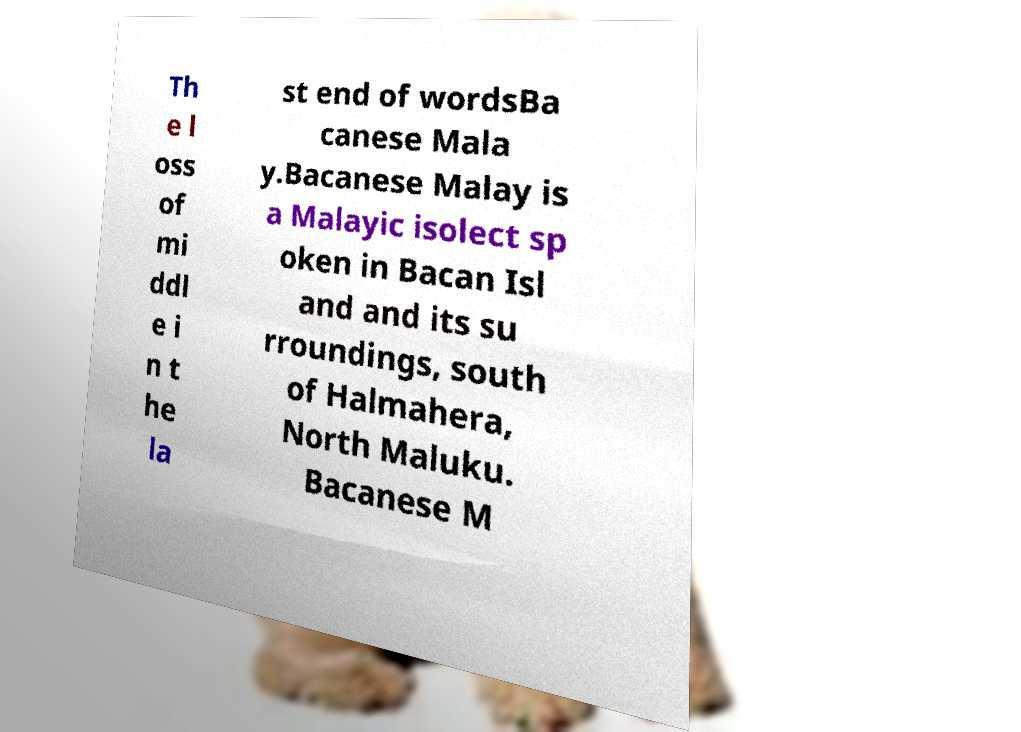Can you read and provide the text displayed in the image?This photo seems to have some interesting text. Can you extract and type it out for me? Th e l oss of mi ddl e i n t he la st end of wordsBa canese Mala y.Bacanese Malay is a Malayic isolect sp oken in Bacan Isl and and its su rroundings, south of Halmahera, North Maluku. Bacanese M 